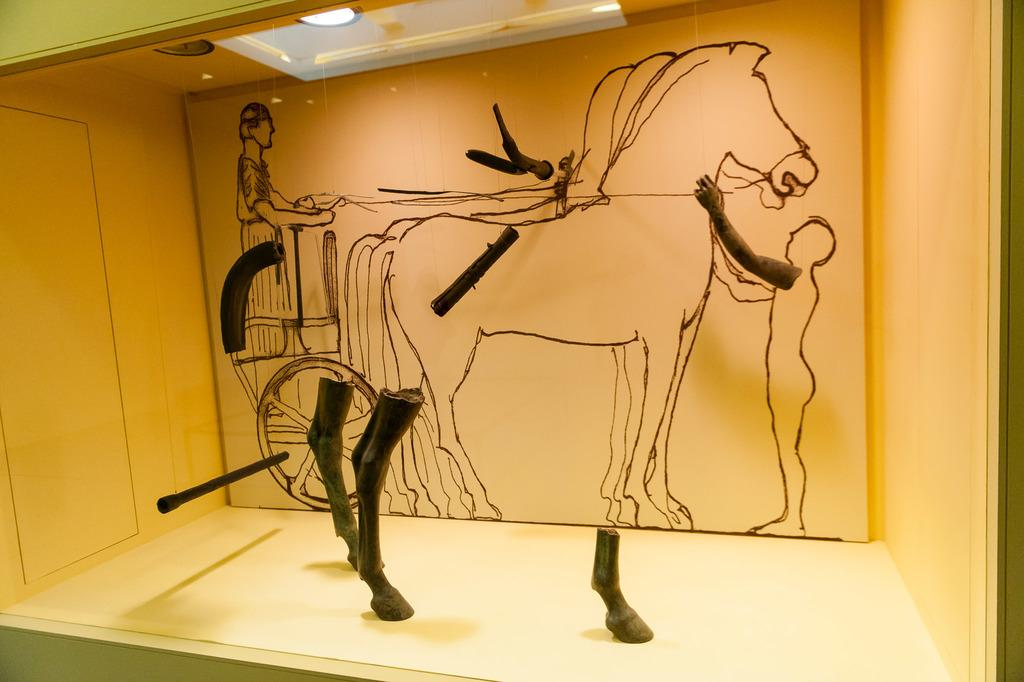What is depicted in the painting that is visible in the image? There is a painting of horses in the image. Where is the painting located? The painting is on a wall. What other objects can be seen in the image? There are wooden sticks visible in the image. How does the painting make the room quieter in the image? The painting does not have any effect on the room's noise level in the image; it is simply a decorative piece on the wall. 